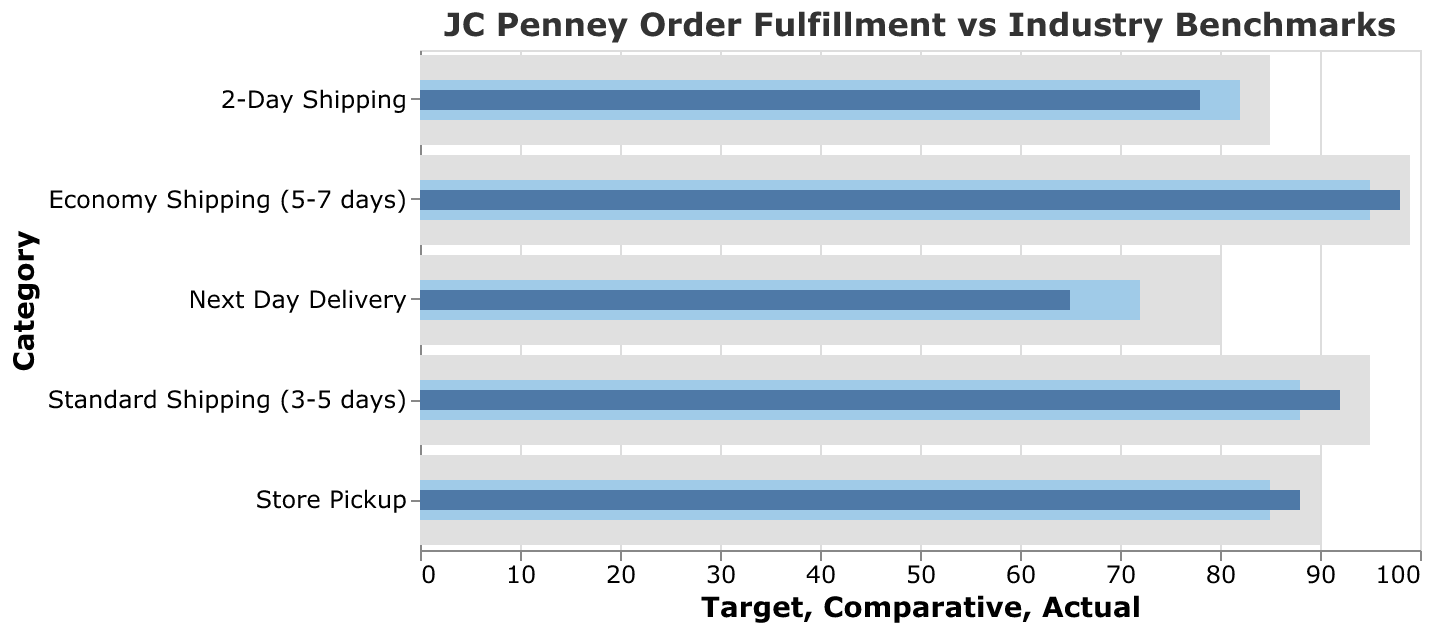what is the title of the figure? The title of the figure is located at the top and it reads "JC Penney Order Fulfillment vs Industry Benchmarks".
Answer: JC Penney Order Fulfillment vs Industry Benchmarks How is the actual percentage of next-day delivery compared to its target? By looking at the bar lengths for "Next Day Delivery", the actual percentage (65) is shorter than the target percentage (80).
Answer: Lower Which shipping category has JC Penney exceeded its industry benchmark? By comparing the lengths of blue bars (actual) to light blue bars (comparative), JC Penney has exceeded the industry benchmark in "Standard Shipping (3-5 days)".
Answer: Standard Shipping (3-5 days) How close is JC Penney to reaching its target in the "Economy Shipping (5-7 days)" category? By comparing the blue bar (98) to the gray bar (99), JC Penney is just 1% away from reaching its target in the "Economy Shipping (5-7 days)" category.
Answer: 1% What's the difference between the actual and target percentages for store pickup? The actual percentage for "Store Pickup" is 88, and the target is 90. The difference between them is 90 - 88 = 2.
Answer: 2 Which shipping category shows the biggest gap between actual and target percentages? By comparing the gaps in the lengths of the blue bars (actual) and gray bars (target), "Next Day Delivery" shows the biggest gap (80 - 65 = 15).
Answer: Next Day Delivery Is JC Penney's performance in "2-Day Shipping" above or below the industry benchmark? For the "2-Day Shipping" category, the blue bar (actual) is shorter than the light blue bar (comparative), indicating JC Penney's performance is below the industry benchmark.
Answer: Below Rank the shipping categories in ascending order based on their actual percentages. Looking at the actual percentages, ranking them in ascending order: Next Day Delivery (65), 2-Day Shipping (78), Store Pickup (88), Standard Shipping (92), Economy Shipping (98).
Answer: Next Day Delivery, 2-Day Shipping, Store Pickup, Standard Shipping, Economy Shipping What is the comparative percentage for "Standard Shipping (3-5 days)" and how does it compare to the target? The comparative percentage for "Standard Shipping (3-5 days)" is 88. To compare it with the target, 88 is less than the target percentage of 95.
Answer: 88, less than target 